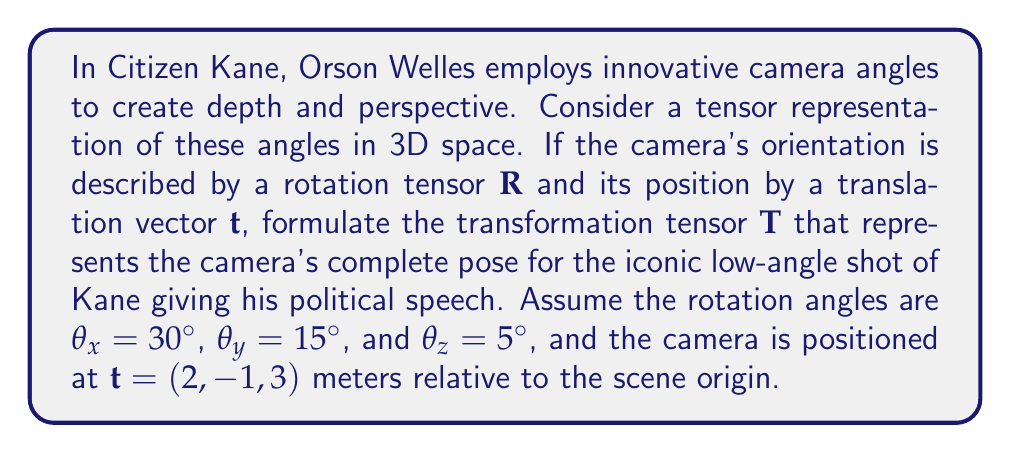Help me with this question. To solve this problem, we'll follow these steps:

1) First, we need to construct the rotation tensor $\mathbf{R}$ using the given angles. We'll use the 3D rotation matrix representation:

   $$\mathbf{R} = \mathbf{R}_z(\theta_z) \mathbf{R}_y(\theta_y) \mathbf{R}_x(\theta_x)$$

   Where:
   $$\mathbf{R}_x(\theta) = \begin{pmatrix}
   1 & 0 & 0 \\
   0 & \cos\theta & -\sin\theta \\
   0 & \sin\theta & \cos\theta
   \end{pmatrix}$$

   $$\mathbf{R}_y(\theta) = \begin{pmatrix}
   \cos\theta & 0 & \sin\theta \\
   0 & 1 & 0 \\
   -\sin\theta & 0 & \cos\theta
   \end{pmatrix}$$

   $$\mathbf{R}_z(\theta) = \begin{pmatrix}
   \cos\theta & -\sin\theta & 0 \\
   \sin\theta & \cos\theta & 0 \\
   0 & 0 & 1
   \end{pmatrix}$$

2) We'll calculate each rotation matrix separately:

   $\mathbf{R}_x(30°)$, $\mathbf{R}_y(15°)$, $\mathbf{R}_z(5°)$

3) Multiply these matrices to get the final rotation tensor $\mathbf{R}$.

4) The translation vector is already given as $\mathbf{t} = (2, -1, 3)$.

5) To represent both rotation and translation in a single transformation, we'll use a 4x4 homogeneous transformation matrix:

   $$\mathbf{T} = \begin{pmatrix}
   \mathbf{R} & \mathbf{t} \\
   0 & 1
   \end{pmatrix}$$

6) Calculate the final transformation tensor $\mathbf{T}$ by combining $\mathbf{R}$ and $\mathbf{t}$.

Calculating the rotation matrices:

$\mathbf{R}_x(30°) = \begin{pmatrix}
1 & 0 & 0 \\
0 & 0.866 & -0.5 \\
0 & 0.5 & 0.866
\end{pmatrix}$

$\mathbf{R}_y(15°) = \begin{pmatrix}
0.966 & 0 & 0.259 \\
0 & 1 & 0 \\
-0.259 & 0 & 0.966
\end{pmatrix}$

$\mathbf{R}_z(5°) = \begin{pmatrix}
0.996 & -0.087 & 0 \\
0.087 & 0.996 & 0 \\
0 & 0 & 1
\end{pmatrix}$

Multiplying these matrices:

$\mathbf{R} = \mathbf{R}_z(5°) \mathbf{R}_y(15°) \mathbf{R}_x(30°) \approx \begin{pmatrix}
0.963 & -0.107 & 0.247 \\
0.131 & 0.991 & -0.033 \\
-0.235 & 0.080 & 0.968
\end{pmatrix}$

Now, we can form the final transformation tensor:

$\mathbf{T} = \begin{pmatrix}
0.963 & -0.107 & 0.247 & 2 \\
0.131 & 0.991 & -0.033 & -1 \\
-0.235 & 0.080 & 0.968 & 3 \\
0 & 0 & 0 & 1
\end{pmatrix}$
Answer: $$\mathbf{T} = \begin{pmatrix}
0.963 & -0.107 & 0.247 & 2 \\
0.131 & 0.991 & -0.033 & -1 \\
-0.235 & 0.080 & 0.968 & 3 \\
0 & 0 & 0 & 1
\end{pmatrix}$$ 